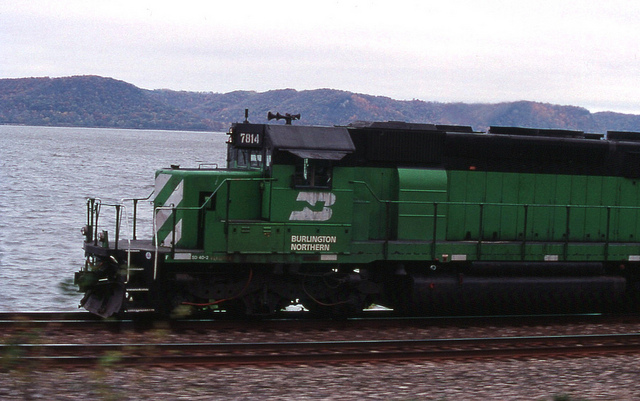<image>What country is this train from? It is unknown what country this train is from. It could be either from Canada or America. What country is this train from? It is ambiguous what country this train is from. It can be both from Canada or the USA. 